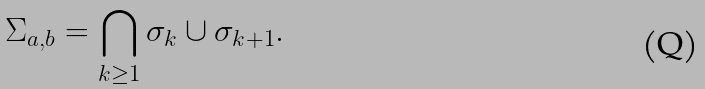<formula> <loc_0><loc_0><loc_500><loc_500>\Sigma _ { a , b } = \bigcap _ { k \geq 1 } \sigma _ { k } \cup \sigma _ { k + 1 } .</formula> 